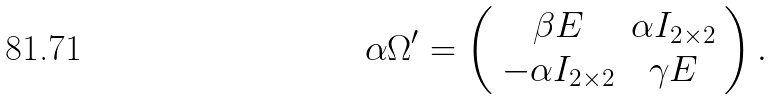Convert formula to latex. <formula><loc_0><loc_0><loc_500><loc_500>\alpha { \Omega } ^ { \prime } = \left ( \begin{array} { c c } \beta { E } & \alpha { I } _ { 2 \times 2 } \\ - \alpha { I } _ { 2 \times 2 } & \gamma { E } \end{array} \right ) .</formula> 